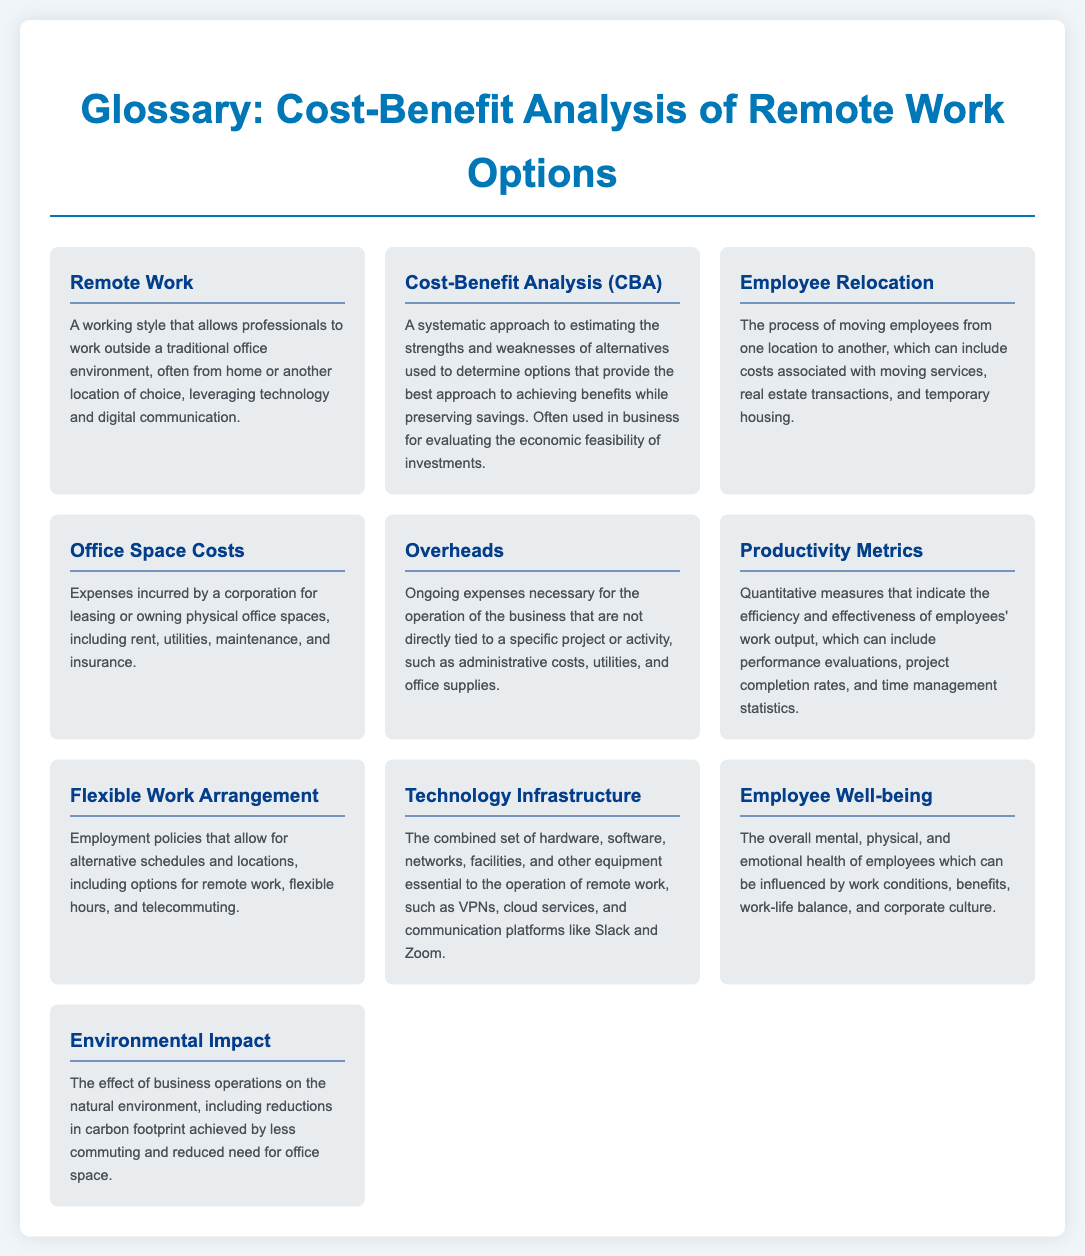what is the term for working outside a traditional office environment? The term refers to a working style that allows professionals to work from home or another location of choice.
Answer: Remote Work what is the purpose of Cost-Benefit Analysis? It is a systematic approach to estimating strengths and weaknesses of alternatives for good economic feasibility of investments.
Answer: To determine the best approach achieving benefits while preserving savings what does Employee Relocation refer to? It refers to the process of moving employees from one location to another, including related costs.
Answer: The process of moving employees from one location to another what types of expenses are included in Office Space Costs? These are expenses incurred for leasing or owning physical office spaces, including rent and utilities.
Answer: Rent, utilities, maintenance, and insurance what are Overheads? These are ongoing expenses necessary for business operation that aren't directly tied to a specific project.
Answer: Ongoing expenses necessary for the operation of the business what is encompassed under Technology Infrastructure? It includes hardware, software, networks, and equipment essential for remote work operations.
Answer: Hardware, software, networks, facilities, and other equipment how does remote work affect Employee Well-being? It can influence overall mental, physical, and emotional health through work conditions and work-life balance.
Answer: Overall mental, physical, and emotional health what can be a positive Environmental Impact of remote work? Less commuting and reduced need for office space can decrease the carbon footprint.
Answer: Reductions in carbon footprint what is a Flexible Work Arrangement? It allows alternative schedules and work locations, including remote work and flexible hours.
Answer: Employment policies for alternative schedules and locations what do Productivity Metrics indicate? They are quantitative measures that indicate the efficiency and effectiveness of employees' work output.
Answer: The efficiency and effectiveness of employees' work output 